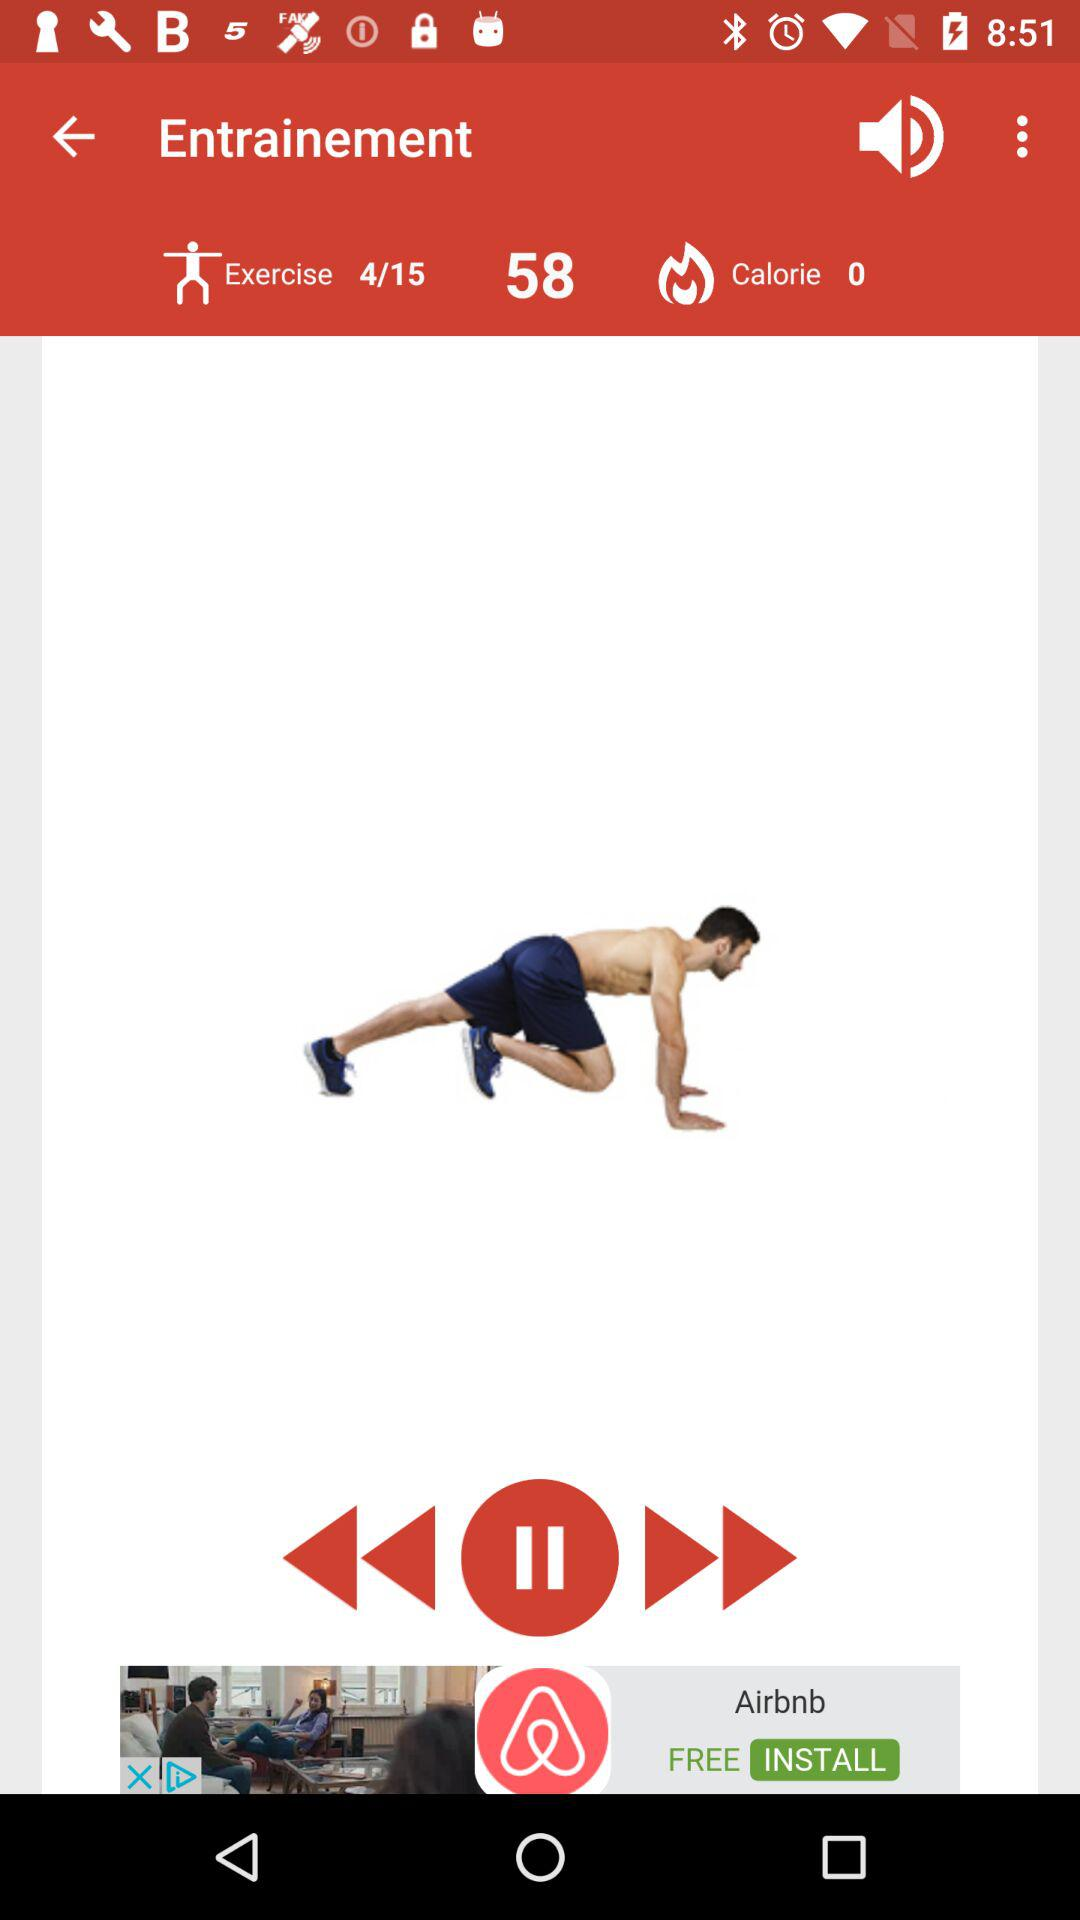How many total exercises are there? The total exercises are 15. 